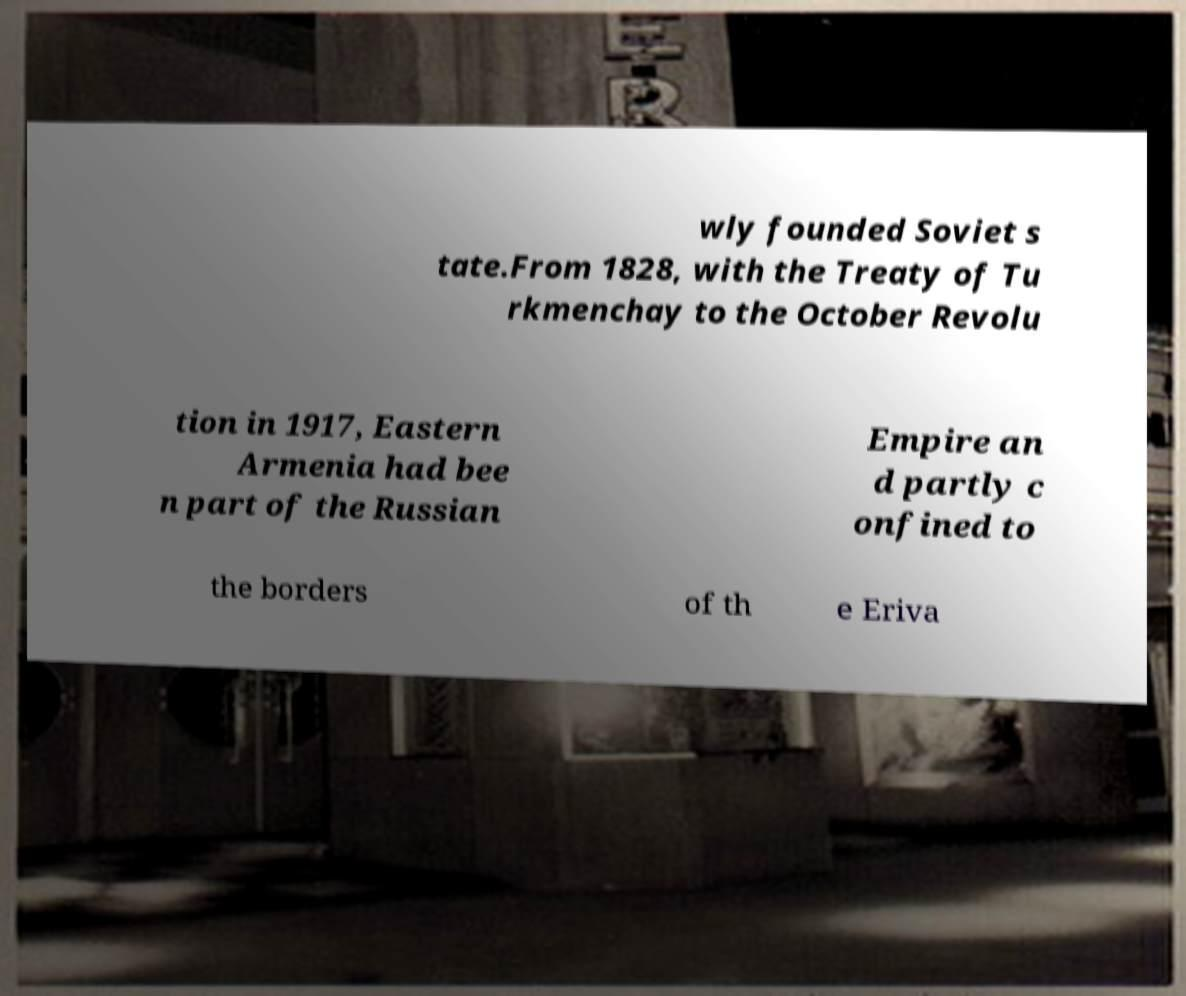Could you assist in decoding the text presented in this image and type it out clearly? wly founded Soviet s tate.From 1828, with the Treaty of Tu rkmenchay to the October Revolu tion in 1917, Eastern Armenia had bee n part of the Russian Empire an d partly c onfined to the borders of th e Eriva 